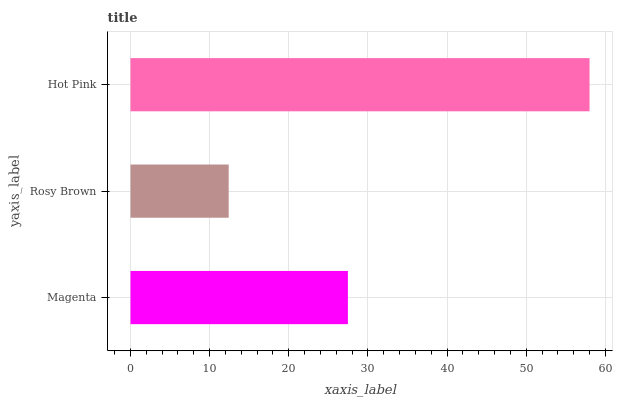Is Rosy Brown the minimum?
Answer yes or no. Yes. Is Hot Pink the maximum?
Answer yes or no. Yes. Is Hot Pink the minimum?
Answer yes or no. No. Is Rosy Brown the maximum?
Answer yes or no. No. Is Hot Pink greater than Rosy Brown?
Answer yes or no. Yes. Is Rosy Brown less than Hot Pink?
Answer yes or no. Yes. Is Rosy Brown greater than Hot Pink?
Answer yes or no. No. Is Hot Pink less than Rosy Brown?
Answer yes or no. No. Is Magenta the high median?
Answer yes or no. Yes. Is Magenta the low median?
Answer yes or no. Yes. Is Rosy Brown the high median?
Answer yes or no. No. Is Rosy Brown the low median?
Answer yes or no. No. 